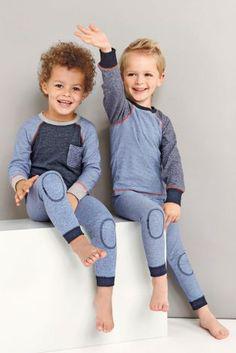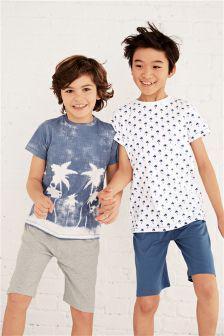The first image is the image on the left, the second image is the image on the right. Evaluate the accuracy of this statement regarding the images: "A boy and girl in the image on the left are sitting down.". Is it true? Answer yes or no. Yes. The first image is the image on the left, the second image is the image on the right. Considering the images on both sides, is "An image shows a child modeling a striped top and bottom." valid? Answer yes or no. No. 